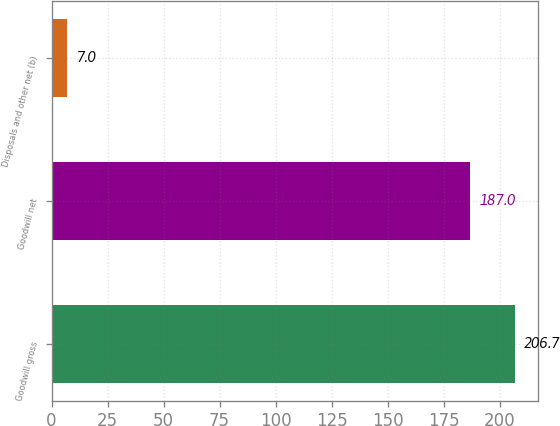Convert chart. <chart><loc_0><loc_0><loc_500><loc_500><bar_chart><fcel>Goodwill gross<fcel>Goodwill net<fcel>Disposals and other net (b)<nl><fcel>206.7<fcel>187<fcel>7<nl></chart> 